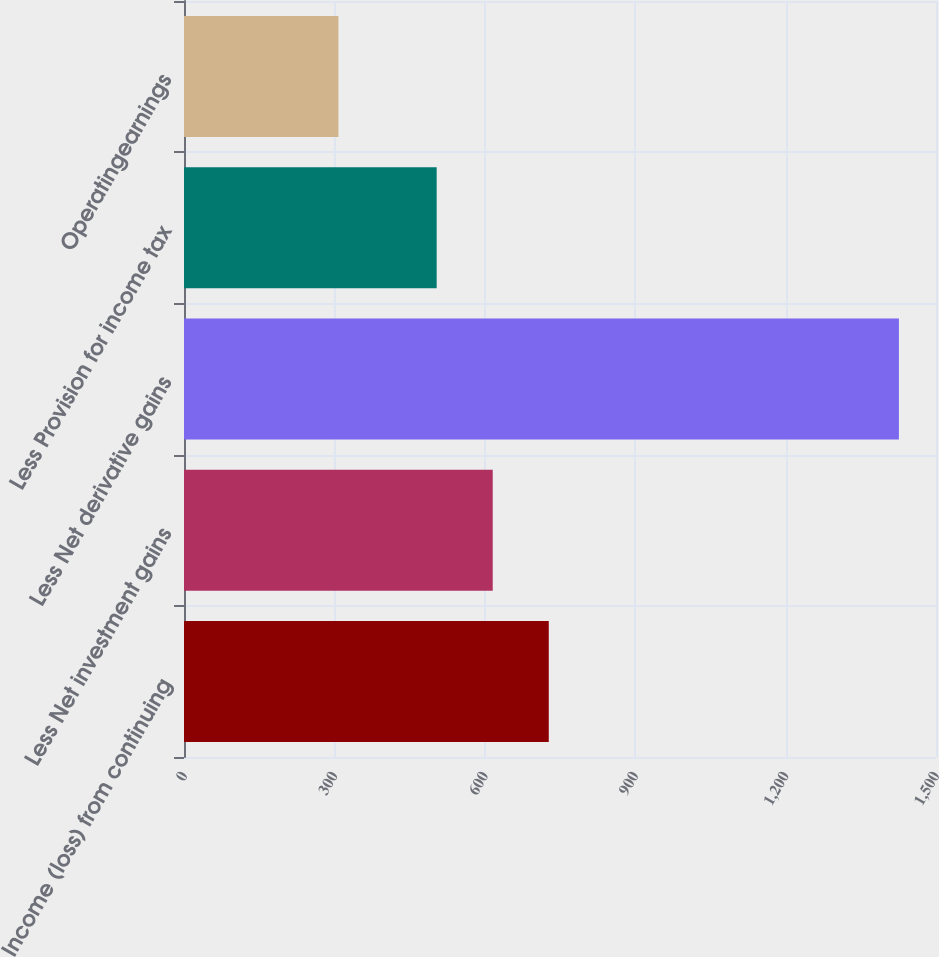Convert chart. <chart><loc_0><loc_0><loc_500><loc_500><bar_chart><fcel>Income (loss) from continuing<fcel>Less Net investment gains<fcel>Less Net derivative gains<fcel>Less Provision for income tax<fcel>Operatingearnings<nl><fcel>727.6<fcel>615.8<fcel>1426<fcel>504<fcel>308<nl></chart> 